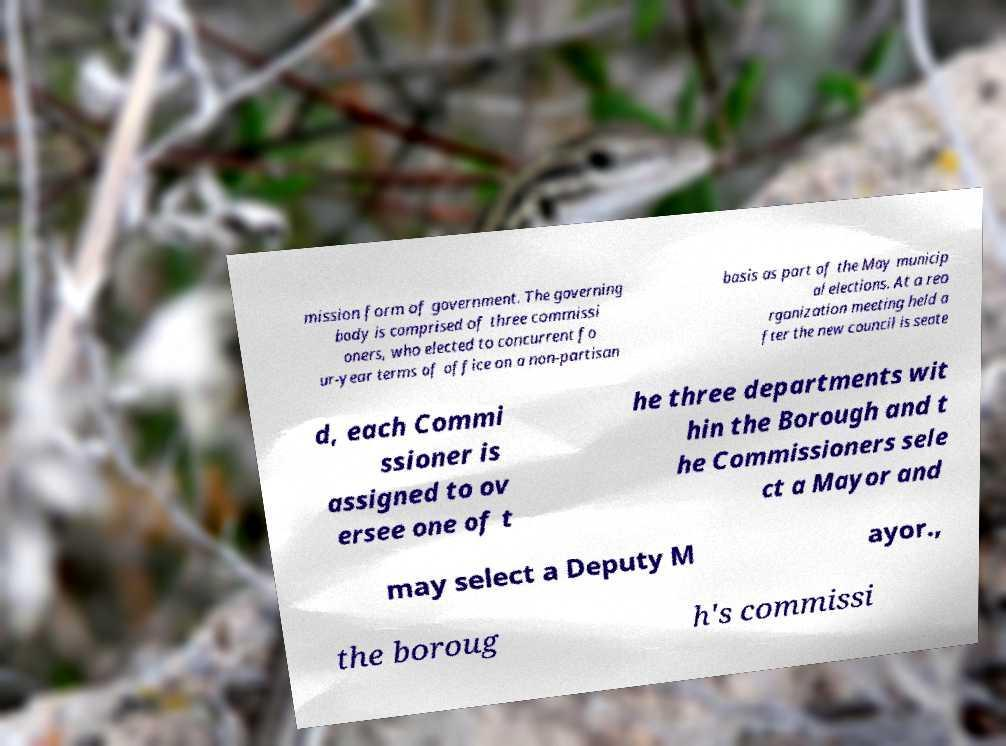Could you assist in decoding the text presented in this image and type it out clearly? mission form of government. The governing body is comprised of three commissi oners, who elected to concurrent fo ur-year terms of office on a non-partisan basis as part of the May municip al elections. At a reo rganization meeting held a fter the new council is seate d, each Commi ssioner is assigned to ov ersee one of t he three departments wit hin the Borough and t he Commissioners sele ct a Mayor and may select a Deputy M ayor., the boroug h's commissi 